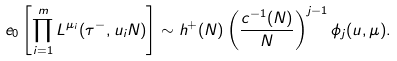<formula> <loc_0><loc_0><loc_500><loc_500>\ e _ { 0 } \left [ \prod _ { i = 1 } ^ { m } L ^ { \mu _ { i } } ( \tau ^ { - } , u _ { i } N ) \right ] \sim h ^ { + } ( N ) \left ( \frac { c ^ { - 1 } ( N ) } { N } \right ) ^ { j - 1 } \phi _ { j } ( u , \mu ) .</formula> 